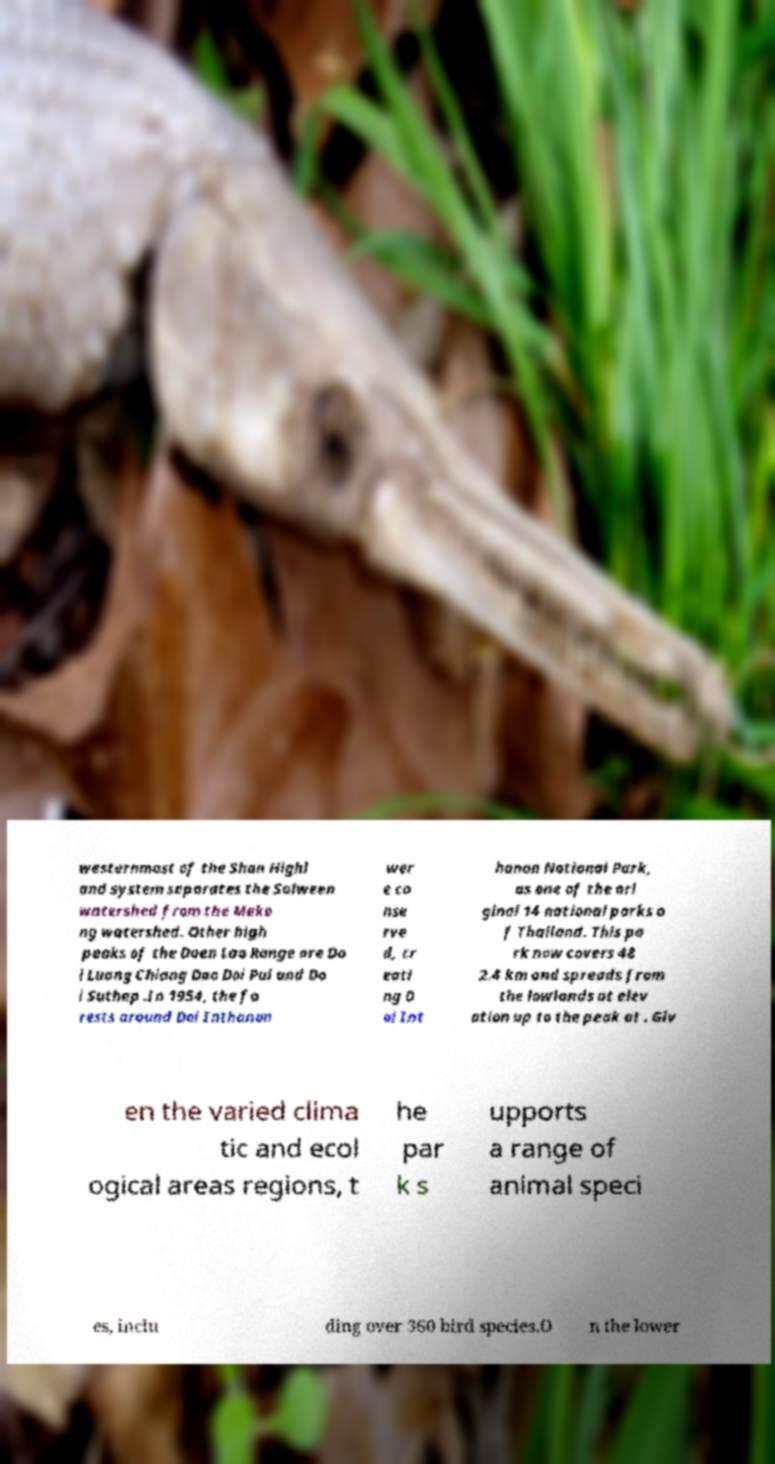I need the written content from this picture converted into text. Can you do that? westernmost of the Shan Highl and system separates the Salween watershed from the Meko ng watershed. Other high peaks of the Daen Lao Range are Do i Luang Chiang Dao Doi Pui and Do i Suthep .In 1954, the fo rests around Doi Inthanon wer e co nse rve d, cr eati ng D oi Int hanon National Park, as one of the ori ginal 14 national parks o f Thailand. This pa rk now covers 48 2.4 km and spreads from the lowlands at elev ation up to the peak at . Giv en the varied clima tic and ecol ogical areas regions, t he par k s upports a range of animal speci es, inclu ding over 360 bird species.O n the lower 